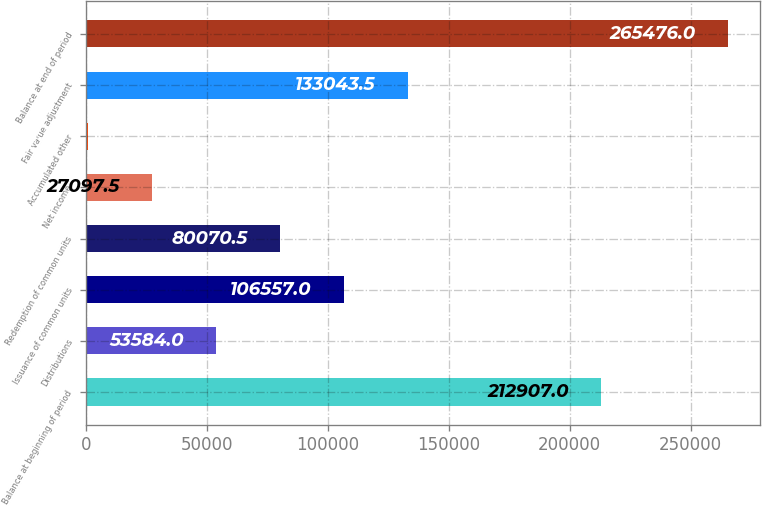Convert chart to OTSL. <chart><loc_0><loc_0><loc_500><loc_500><bar_chart><fcel>Balance at beginning of period<fcel>Distributions<fcel>Issuance of common units<fcel>Redemption of common units<fcel>Net income<fcel>Accumulated other<fcel>Fair value adjustment<fcel>Balance at end of period<nl><fcel>212907<fcel>53584<fcel>106557<fcel>80070.5<fcel>27097.5<fcel>611<fcel>133044<fcel>265476<nl></chart> 